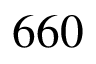<formula> <loc_0><loc_0><loc_500><loc_500>6 6 0</formula> 